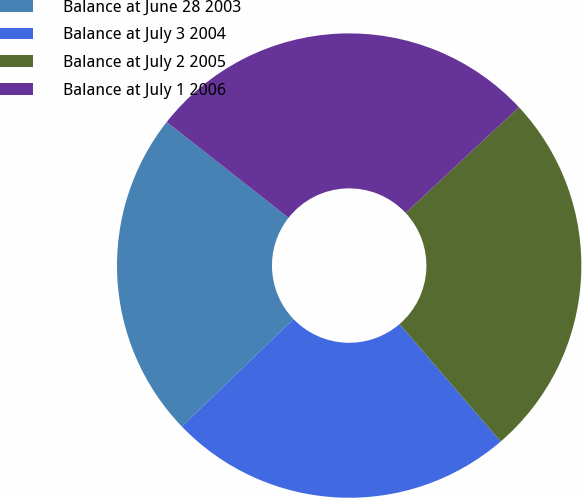Convert chart. <chart><loc_0><loc_0><loc_500><loc_500><pie_chart><fcel>Balance at June 28 2003<fcel>Balance at July 3 2004<fcel>Balance at July 2 2005<fcel>Balance at July 1 2006<nl><fcel>22.8%<fcel>24.13%<fcel>25.63%<fcel>27.44%<nl></chart> 